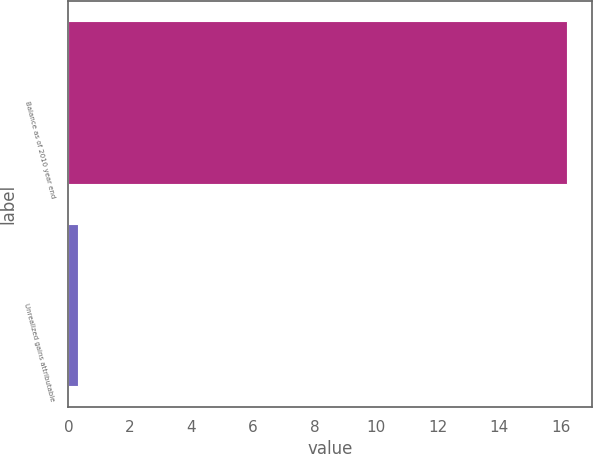Convert chart. <chart><loc_0><loc_0><loc_500><loc_500><bar_chart><fcel>Balance as of 2010 year end<fcel>Unrealized gains attributable<nl><fcel>16.2<fcel>0.3<nl></chart> 